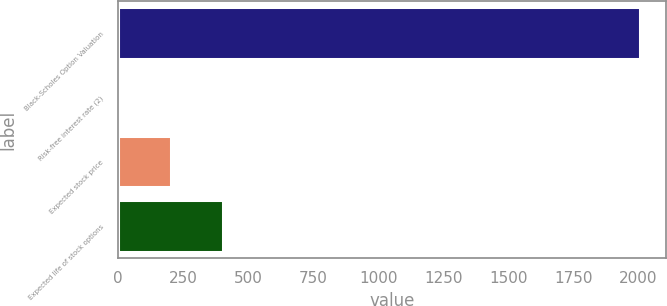<chart> <loc_0><loc_0><loc_500><loc_500><bar_chart><fcel>Black-Scholes Option Valuation<fcel>Risk-free interest rate (2)<fcel>Expected stock price<fcel>Expected life of stock options<nl><fcel>2005<fcel>3.7<fcel>203.83<fcel>403.96<nl></chart> 